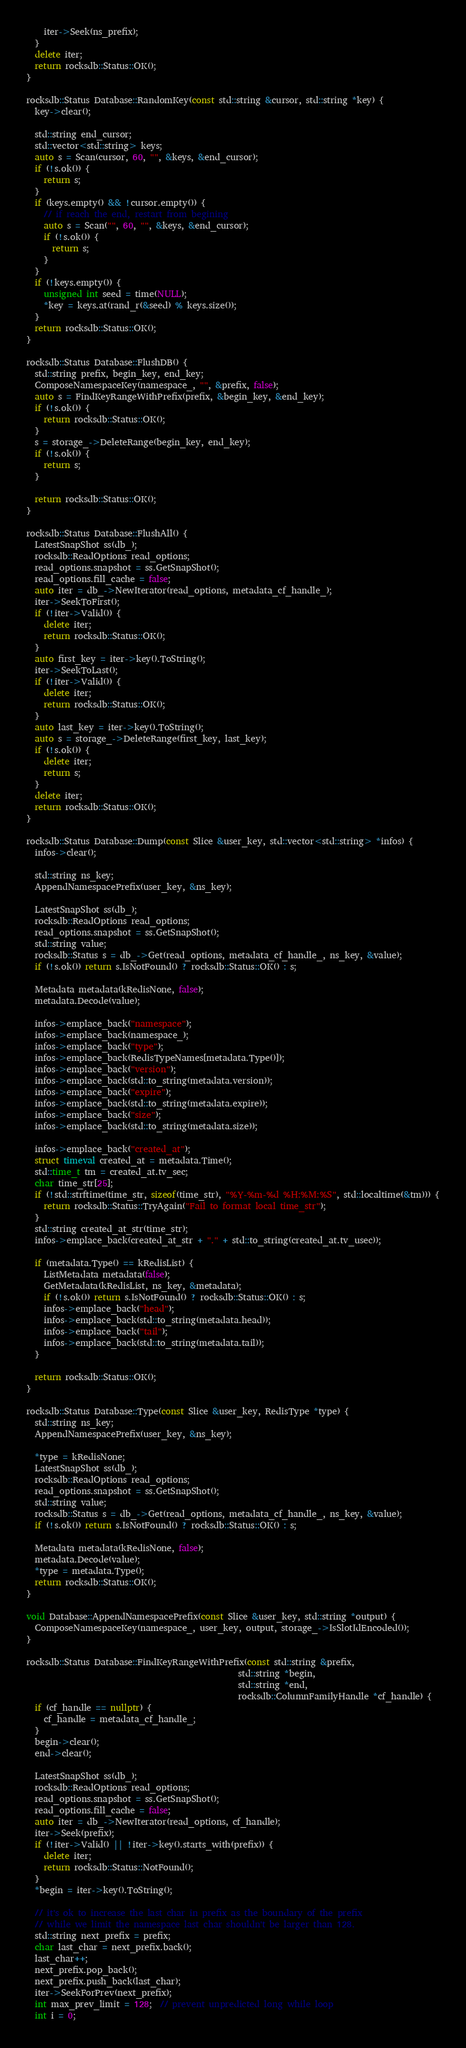<code> <loc_0><loc_0><loc_500><loc_500><_C++_>    iter->Seek(ns_prefix);
  }
  delete iter;
  return rocksdb::Status::OK();
}

rocksdb::Status Database::RandomKey(const std::string &cursor, std::string *key) {
  key->clear();

  std::string end_cursor;
  std::vector<std::string> keys;
  auto s = Scan(cursor, 60, "", &keys, &end_cursor);
  if (!s.ok()) {
    return s;
  }
  if (keys.empty() && !cursor.empty()) {
    // if reach the end, restart from begining
    auto s = Scan("", 60, "", &keys, &end_cursor);
    if (!s.ok()) {
      return s;
    }
  }
  if (!keys.empty()) {
    unsigned int seed = time(NULL);
    *key = keys.at(rand_r(&seed) % keys.size());
  }
  return rocksdb::Status::OK();
}

rocksdb::Status Database::FlushDB() {
  std::string prefix, begin_key, end_key;
  ComposeNamespaceKey(namespace_, "", &prefix, false);
  auto s = FindKeyRangeWithPrefix(prefix, &begin_key, &end_key);
  if (!s.ok()) {
    return rocksdb::Status::OK();
  }
  s = storage_->DeleteRange(begin_key, end_key);
  if (!s.ok()) {
    return s;
  }

  return rocksdb::Status::OK();
}

rocksdb::Status Database::FlushAll() {
  LatestSnapShot ss(db_);
  rocksdb::ReadOptions read_options;
  read_options.snapshot = ss.GetSnapShot();
  read_options.fill_cache = false;
  auto iter = db_->NewIterator(read_options, metadata_cf_handle_);
  iter->SeekToFirst();
  if (!iter->Valid()) {
    delete iter;
    return rocksdb::Status::OK();
  }
  auto first_key = iter->key().ToString();
  iter->SeekToLast();
  if (!iter->Valid()) {
    delete iter;
    return rocksdb::Status::OK();
  }
  auto last_key = iter->key().ToString();
  auto s = storage_->DeleteRange(first_key, last_key);
  if (!s.ok()) {
    delete iter;
    return s;
  }
  delete iter;
  return rocksdb::Status::OK();
}

rocksdb::Status Database::Dump(const Slice &user_key, std::vector<std::string> *infos) {
  infos->clear();

  std::string ns_key;
  AppendNamespacePrefix(user_key, &ns_key);

  LatestSnapShot ss(db_);
  rocksdb::ReadOptions read_options;
  read_options.snapshot = ss.GetSnapShot();
  std::string value;
  rocksdb::Status s = db_->Get(read_options, metadata_cf_handle_, ns_key, &value);
  if (!s.ok()) return s.IsNotFound() ? rocksdb::Status::OK() : s;

  Metadata metadata(kRedisNone, false);
  metadata.Decode(value);

  infos->emplace_back("namespace");
  infos->emplace_back(namespace_);
  infos->emplace_back("type");
  infos->emplace_back(RedisTypeNames[metadata.Type()]);
  infos->emplace_back("version");
  infos->emplace_back(std::to_string(metadata.version));
  infos->emplace_back("expire");
  infos->emplace_back(std::to_string(metadata.expire));
  infos->emplace_back("size");
  infos->emplace_back(std::to_string(metadata.size));

  infos->emplace_back("created_at");
  struct timeval created_at = metadata.Time();
  std::time_t tm = created_at.tv_sec;
  char time_str[25];
  if (!std::strftime(time_str, sizeof(time_str), "%Y-%m-%d %H:%M:%S", std::localtime(&tm))) {
    return rocksdb::Status::TryAgain("Fail to format local time_str");
  }
  std::string created_at_str(time_str);
  infos->emplace_back(created_at_str + "." + std::to_string(created_at.tv_usec));

  if (metadata.Type() == kRedisList) {
    ListMetadata metadata(false);
    GetMetadata(kRedisList, ns_key, &metadata);
    if (!s.ok()) return s.IsNotFound() ? rocksdb::Status::OK() : s;
    infos->emplace_back("head");
    infos->emplace_back(std::to_string(metadata.head));
    infos->emplace_back("tail");
    infos->emplace_back(std::to_string(metadata.tail));
  }

  return rocksdb::Status::OK();
}

rocksdb::Status Database::Type(const Slice &user_key, RedisType *type) {
  std::string ns_key;
  AppendNamespacePrefix(user_key, &ns_key);

  *type = kRedisNone;
  LatestSnapShot ss(db_);
  rocksdb::ReadOptions read_options;
  read_options.snapshot = ss.GetSnapShot();
  std::string value;
  rocksdb::Status s = db_->Get(read_options, metadata_cf_handle_, ns_key, &value);
  if (!s.ok()) return s.IsNotFound() ? rocksdb::Status::OK() : s;

  Metadata metadata(kRedisNone, false);
  metadata.Decode(value);
  *type = metadata.Type();
  return rocksdb::Status::OK();
}

void Database::AppendNamespacePrefix(const Slice &user_key, std::string *output) {
  ComposeNamespaceKey(namespace_, user_key, output, storage_->IsSlotIdEncoded());
}

rocksdb::Status Database::FindKeyRangeWithPrefix(const std::string &prefix,
                                                 std::string *begin,
                                                 std::string *end,
                                                 rocksdb::ColumnFamilyHandle *cf_handle) {
  if (cf_handle == nullptr) {
    cf_handle = metadata_cf_handle_;
  }
  begin->clear();
  end->clear();

  LatestSnapShot ss(db_);
  rocksdb::ReadOptions read_options;
  read_options.snapshot = ss.GetSnapShot();
  read_options.fill_cache = false;
  auto iter = db_->NewIterator(read_options, cf_handle);
  iter->Seek(prefix);
  if (!iter->Valid() || !iter->key().starts_with(prefix)) {
    delete iter;
    return rocksdb::Status::NotFound();
  }
  *begin = iter->key().ToString();

  // it's ok to increase the last char in prefix as the boundary of the prefix
  // while we limit the namespace last char shouldn't be larger than 128.
  std::string next_prefix = prefix;
  char last_char = next_prefix.back();
  last_char++;
  next_prefix.pop_back();
  next_prefix.push_back(last_char);
  iter->SeekForPrev(next_prefix);
  int max_prev_limit = 128;  // prevent unpredicted long while loop
  int i = 0;</code> 